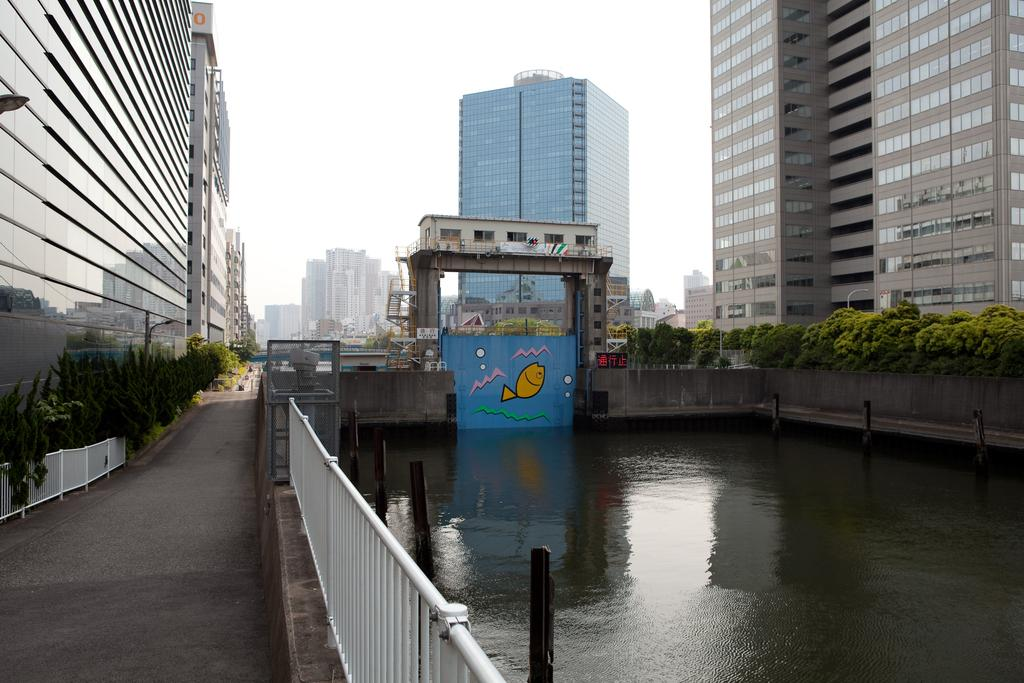What type of natural elements can be seen in the image? There are trees and plants visible in the image. What type of man-made structures can be seen in the image? There are buildings and a fence visible in the image. What other objects can be seen in the image? There are poles and water visible in the image. What is visible in the background of the image? The sky is visible in the background of the image. Can you tell me how many squirrels are sitting on the son's arch in the image? There is no son, arch, or squirrel present in the image. 